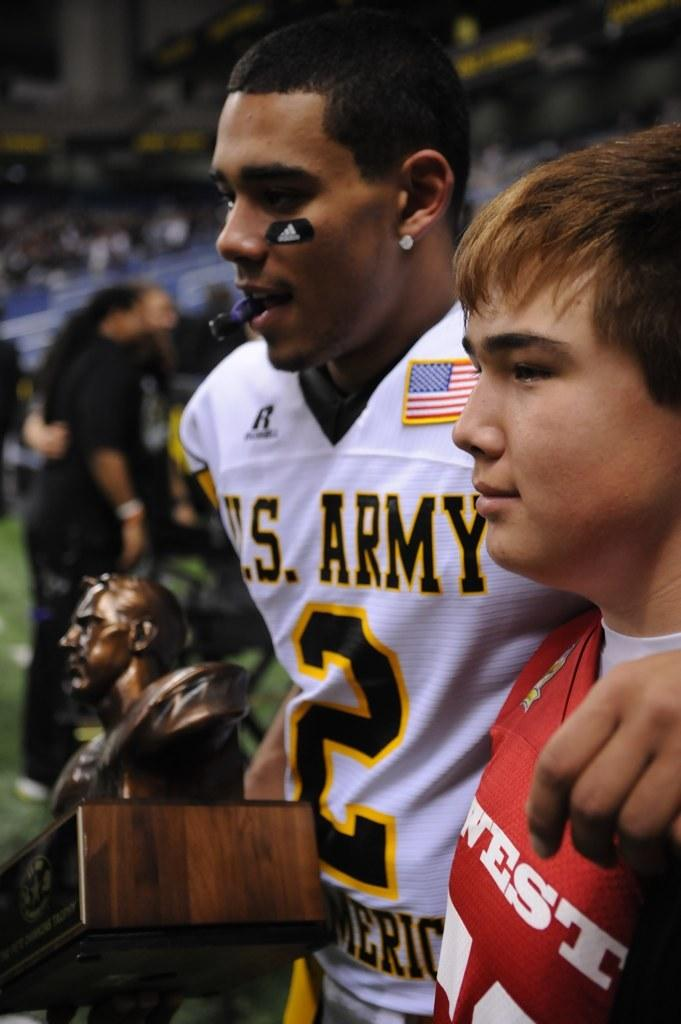How many boys are present in the image? There are two boys in the image. What is the second boy holding in his hand? The second boy is holding an object in his hand. Can you describe the background of the image? The background of the boys is blurred. What type of liquid can be seen spilling from the crate in the image? There is no crate or liquid present in the image. 